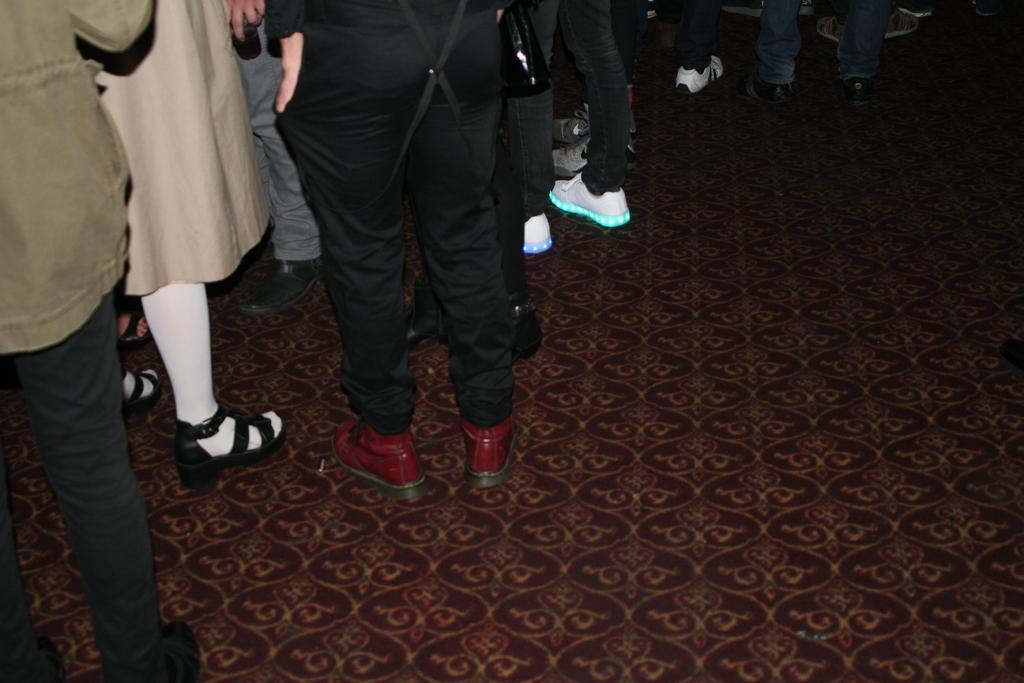Describe this image in one or two sentences. In this picture we can see there are legs of people, which are on the floor. 